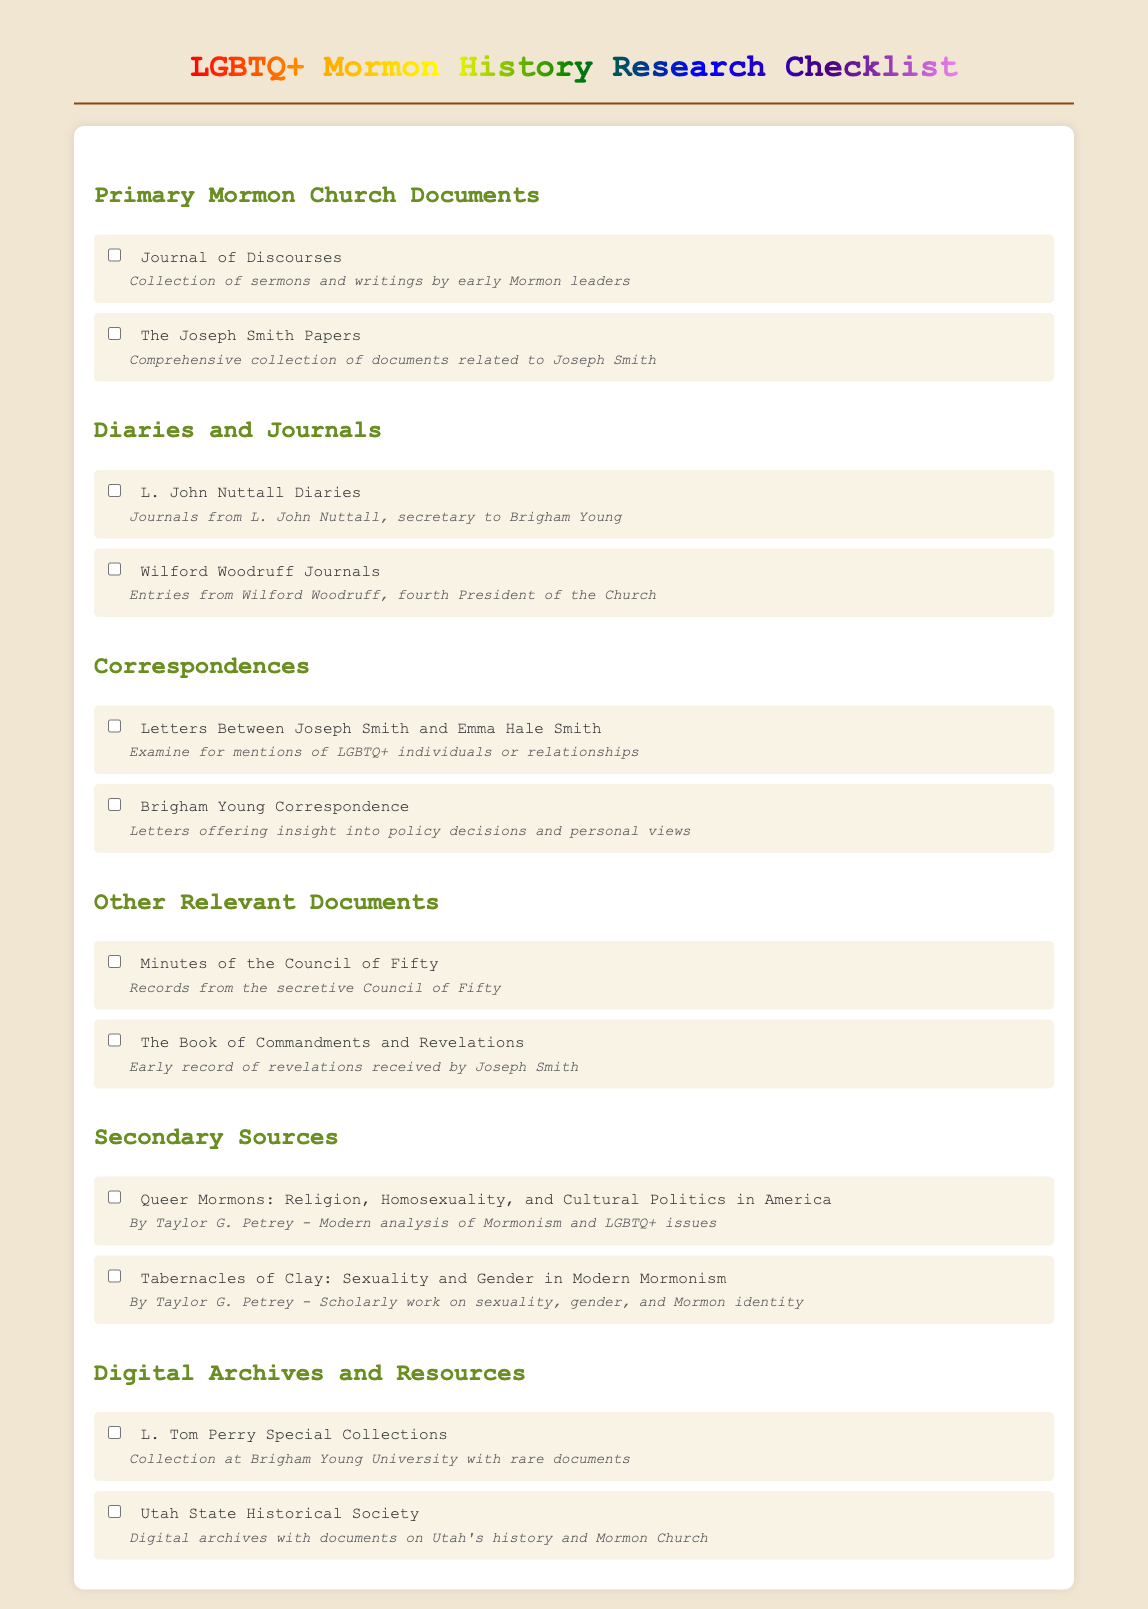What is the title of the checklist? The title is presented at the top of the document, indicating the primary focus of the research.
Answer: LGBTQ+ Mormon History Research Checklist How many sections are included in the checklist? The document organizes its information into distinct sections, allowing for easy reference.
Answer: 5 What is one of the primary documents listed for archival research? This question seeks to identify a specific type of document highlighted in the primary documents section.
Answer: Journal of Discourses Who authored "Tabernacles of Clay"? This question looks for the author of a specific secondary source mentioned in the checklist.
Answer: Taylor G. Petrey What type of collection is the L. Tom Perry Special Collections? The checklist provides specific details regarding the nature of this collection, which relates to the research focus.
Answer: Rare documents What is the description of the "Wilford Woodruff Journals"? This question requires extracting the specific content provided about one of the listed diaries.
Answer: Entries from Wilford Woodruff, fourth President of the Church How many LGBTQ+ related journals are mentioned? This question checks the count of journals specifically identified in the checklist targetting LGBTQ+ narratives in Mormon history.
Answer: 2 What do the minutes of the Council of Fifty record? The question asks about the content type associated with this specific document listed in the checklist.
Answer: Records from the secretive Council of Fifty What is the significant theme of "Queer Mormons: Religion, Homosexuality, and Cultural Politics in America"? The focus of this secondary source is specifically stated, aligning with the overarching checklist theme.
Answer: Modern analysis of Mormonism and LGBTQ+ issues 